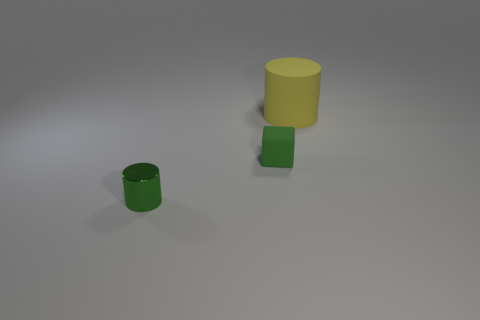Add 1 tiny shiny objects. How many objects exist? 4 Subtract 1 cylinders. How many cylinders are left? 1 Subtract all green cylinders. How many cylinders are left? 1 Subtract all blocks. How many objects are left? 2 Subtract all cylinders. Subtract all green rubber blocks. How many objects are left? 0 Add 2 yellow cylinders. How many yellow cylinders are left? 3 Add 3 tiny blue rubber cubes. How many tiny blue rubber cubes exist? 3 Subtract 0 green spheres. How many objects are left? 3 Subtract all yellow blocks. Subtract all purple balls. How many blocks are left? 1 